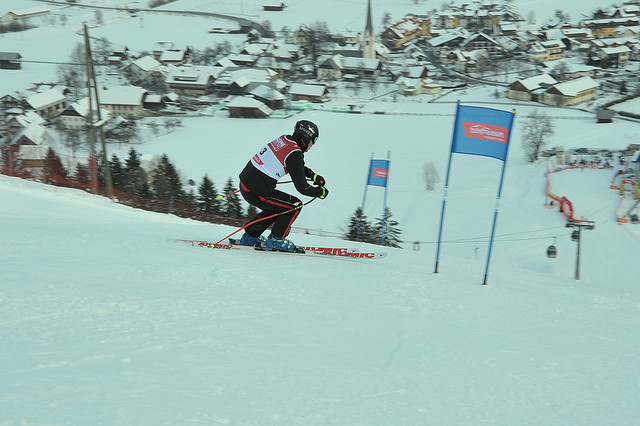Please transcribe the text information in this image. 3 